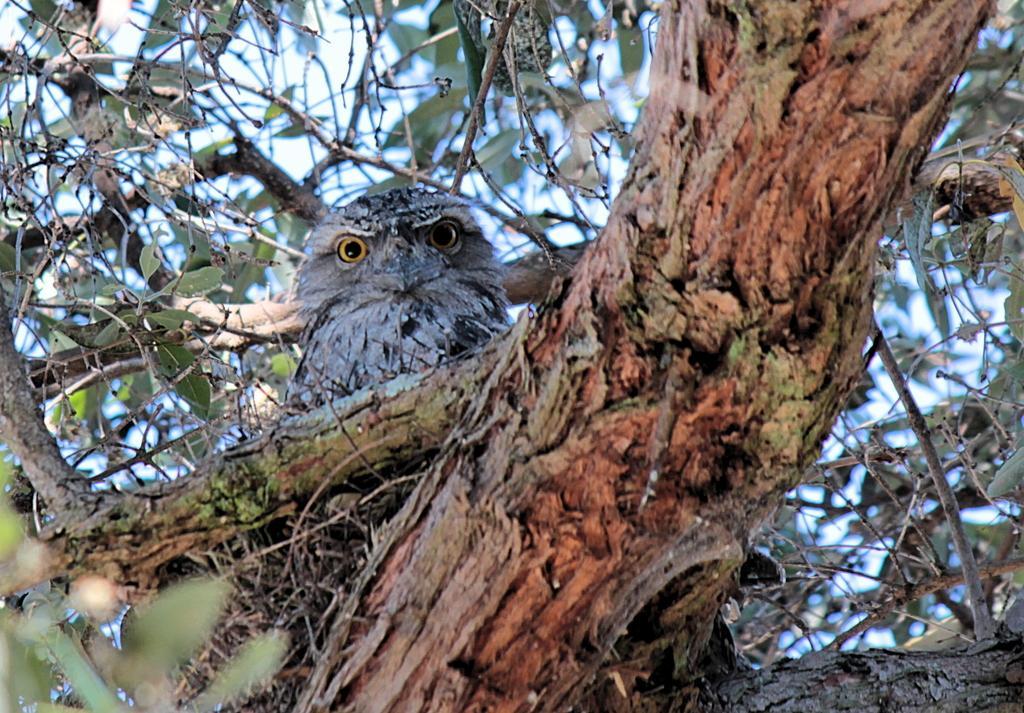In one or two sentences, can you explain what this image depicts? In this image there is a bird in the nest, which is on the branch of a tree having leaves. Behind there is sky. 